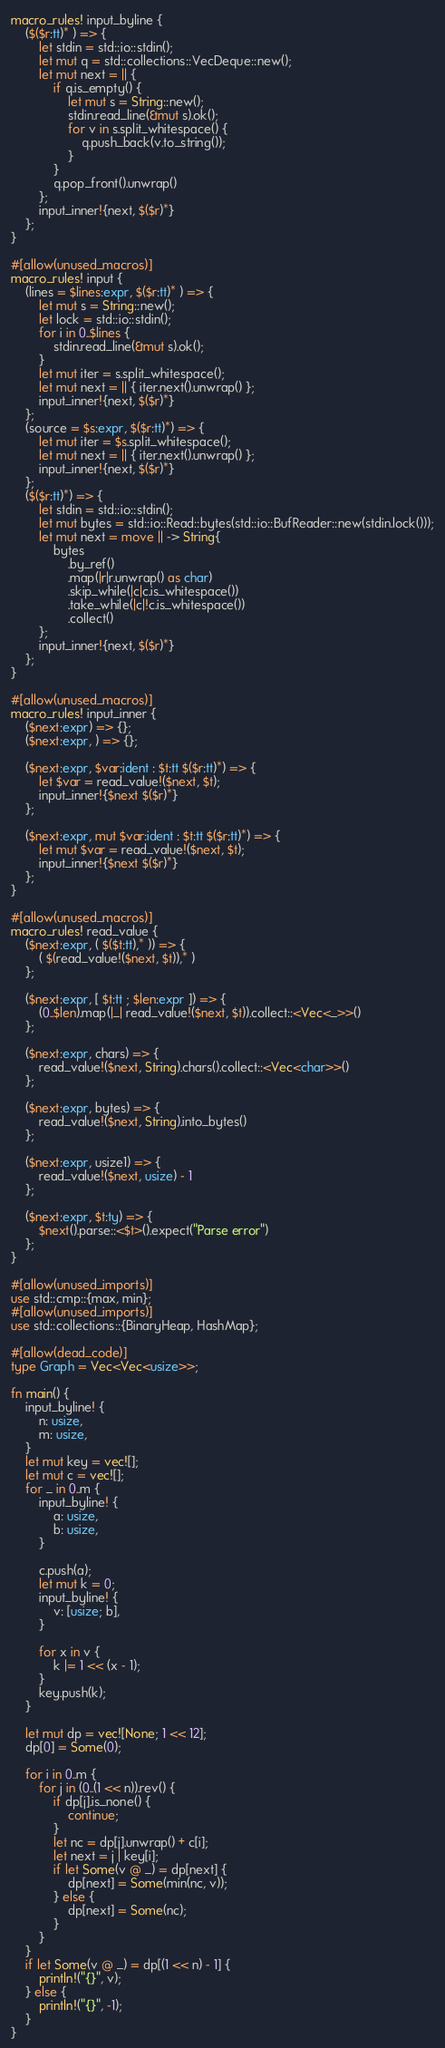Convert code to text. <code><loc_0><loc_0><loc_500><loc_500><_Rust_>macro_rules! input_byline {
    ($($r:tt)* ) => {
        let stdin = std::io::stdin();
        let mut q = std::collections::VecDeque::new();
        let mut next = || {
            if q.is_empty() {
                let mut s = String::new();
                stdin.read_line(&mut s).ok();
                for v in s.split_whitespace() {
                    q.push_back(v.to_string());
                }
            }
            q.pop_front().unwrap()
        };
        input_inner!{next, $($r)*}
    };
}

#[allow(unused_macros)]
macro_rules! input {
    (lines = $lines:expr, $($r:tt)* ) => {
        let mut s = String::new();
        let lock = std::io::stdin();
        for i in 0..$lines {
            stdin.read_line(&mut s).ok();
        }
        let mut iter = s.split_whitespace();
        let mut next = || { iter.next().unwrap() };
        input_inner!{next, $($r)*}
    };
    (source = $s:expr, $($r:tt)*) => {
        let mut iter = $s.split_whitespace();
        let mut next = || { iter.next().unwrap() };
        input_inner!{next, $($r)*}
    };
    ($($r:tt)*) => {
        let stdin = std::io::stdin();
        let mut bytes = std::io::Read::bytes(std::io::BufReader::new(stdin.lock()));
        let mut next = move || -> String{
            bytes
                .by_ref()
                .map(|r|r.unwrap() as char)
                .skip_while(|c|c.is_whitespace())
                .take_while(|c|!c.is_whitespace())
                .collect()
        };
        input_inner!{next, $($r)*}
    };
}

#[allow(unused_macros)]
macro_rules! input_inner {
    ($next:expr) => {};
    ($next:expr, ) => {};

    ($next:expr, $var:ident : $t:tt $($r:tt)*) => {
        let $var = read_value!($next, $t);
        input_inner!{$next $($r)*}
    };

    ($next:expr, mut $var:ident : $t:tt $($r:tt)*) => {
        let mut $var = read_value!($next, $t);
        input_inner!{$next $($r)*}
    };
}

#[allow(unused_macros)]
macro_rules! read_value {
    ($next:expr, ( $($t:tt),* )) => {
        ( $(read_value!($next, $t)),* )
    };

    ($next:expr, [ $t:tt ; $len:expr ]) => {
        (0..$len).map(|_| read_value!($next, $t)).collect::<Vec<_>>()
    };

    ($next:expr, chars) => {
        read_value!($next, String).chars().collect::<Vec<char>>()
    };

    ($next:expr, bytes) => {
        read_value!($next, String).into_bytes()
    };

    ($next:expr, usize1) => {
        read_value!($next, usize) - 1
    };

    ($next:expr, $t:ty) => {
        $next().parse::<$t>().expect("Parse error")
    };
}

#[allow(unused_imports)]
use std::cmp::{max, min};
#[allow(unused_imports)]
use std::collections::{BinaryHeap, HashMap};

#[allow(dead_code)]
type Graph = Vec<Vec<usize>>;

fn main() {
    input_byline! {
        n: usize,
        m: usize,
    }
    let mut key = vec![];
    let mut c = vec![];
    for _ in 0..m {
        input_byline! {
            a: usize,
            b: usize,
        }

        c.push(a);
        let mut k = 0;
        input_byline! {
            v: [usize; b],
        }

        for x in v {
            k |= 1 << (x - 1);
        }
        key.push(k);
    }

    let mut dp = vec![None; 1 << 12];
    dp[0] = Some(0);

    for i in 0..m {
        for j in (0..(1 << n)).rev() {
            if dp[j].is_none() {
                continue;
            }
            let nc = dp[j].unwrap() + c[i];
            let next = j | key[i];
            if let Some(v @ _) = dp[next] {
                dp[next] = Some(min(nc, v));
            } else {
                dp[next] = Some(nc);
            }
        }
    }
    if let Some(v @ _) = dp[(1 << n) - 1] {
        println!("{}", v);
    } else {
        println!("{}", -1);
    }
}
</code> 